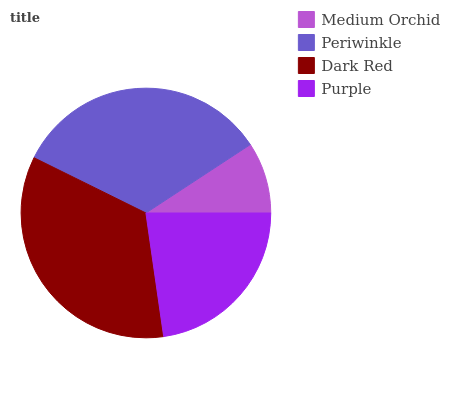Is Medium Orchid the minimum?
Answer yes or no. Yes. Is Dark Red the maximum?
Answer yes or no. Yes. Is Periwinkle the minimum?
Answer yes or no. No. Is Periwinkle the maximum?
Answer yes or no. No. Is Periwinkle greater than Medium Orchid?
Answer yes or no. Yes. Is Medium Orchid less than Periwinkle?
Answer yes or no. Yes. Is Medium Orchid greater than Periwinkle?
Answer yes or no. No. Is Periwinkle less than Medium Orchid?
Answer yes or no. No. Is Periwinkle the high median?
Answer yes or no. Yes. Is Purple the low median?
Answer yes or no. Yes. Is Dark Red the high median?
Answer yes or no. No. Is Medium Orchid the low median?
Answer yes or no. No. 